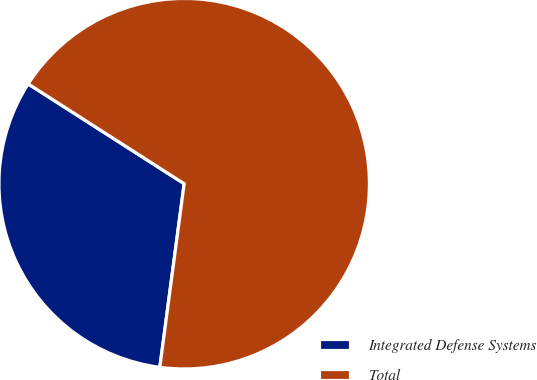Convert chart to OTSL. <chart><loc_0><loc_0><loc_500><loc_500><pie_chart><fcel>Integrated Defense Systems<fcel>Total<nl><fcel>31.96%<fcel>68.04%<nl></chart> 